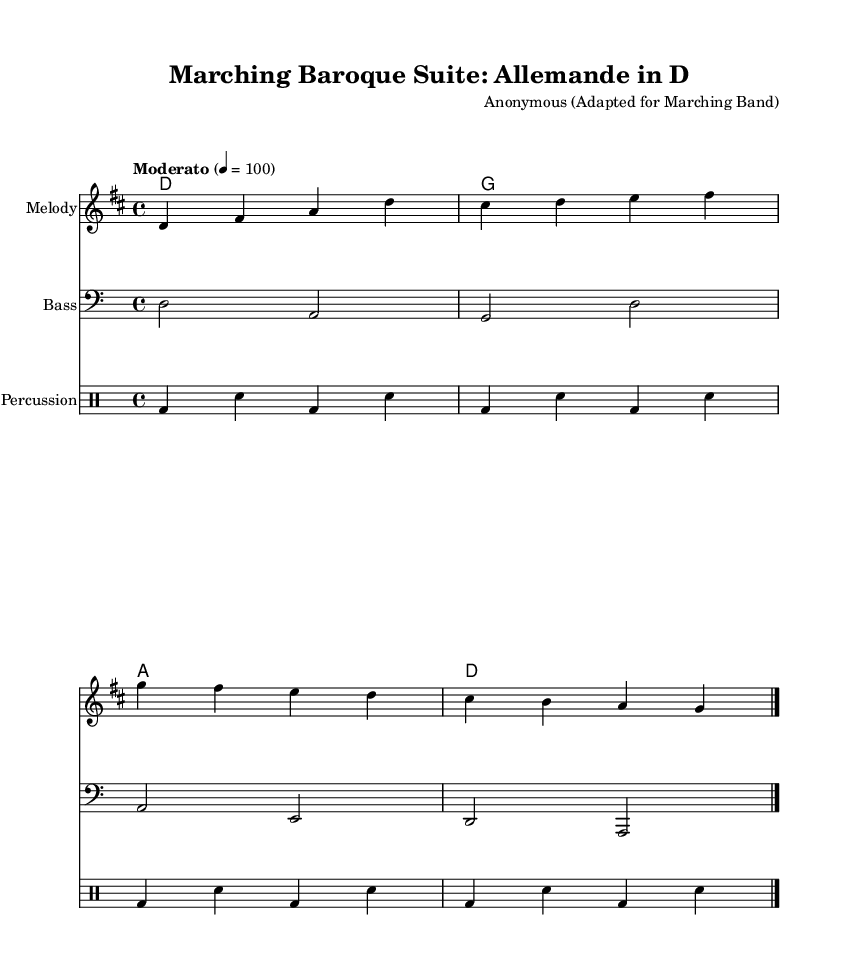What is the key signature of this music? The key signature is D major, which has two sharps (C# and F#) indicated at the beginning of the staff.
Answer: D major What is the time signature of this piece? The time signature is 4/4, shown at the beginning of the piece as a fraction with a top number 4 and a bottom number 4.
Answer: 4/4 What is the tempo marking of the music? The tempo marking is "Moderato" with a metronome marking of 100 beats per minute, explicitly stated in the score.
Answer: Moderato How many measures are in the melody part? The melody part has four measures, as indicated by the four groups of notes separated by vertical lines (bars) in the score.
Answer: Four Identify the first note of the melody. The first note of the melody is D, which is indicated as the starting note in the first measure.
Answer: D What is the instrumentation indicated for the Bass staff? The Bass staff is indicated with the instrument name "Bass," which means this part is meant for a bass instrument to play.
Answer: Bass What type of dance is represented in this adaptation? The dance type represented in this adaptation is an "Allemande," which is a typical dance form from the Baroque period specifically indicated in the title.
Answer: Allemande 